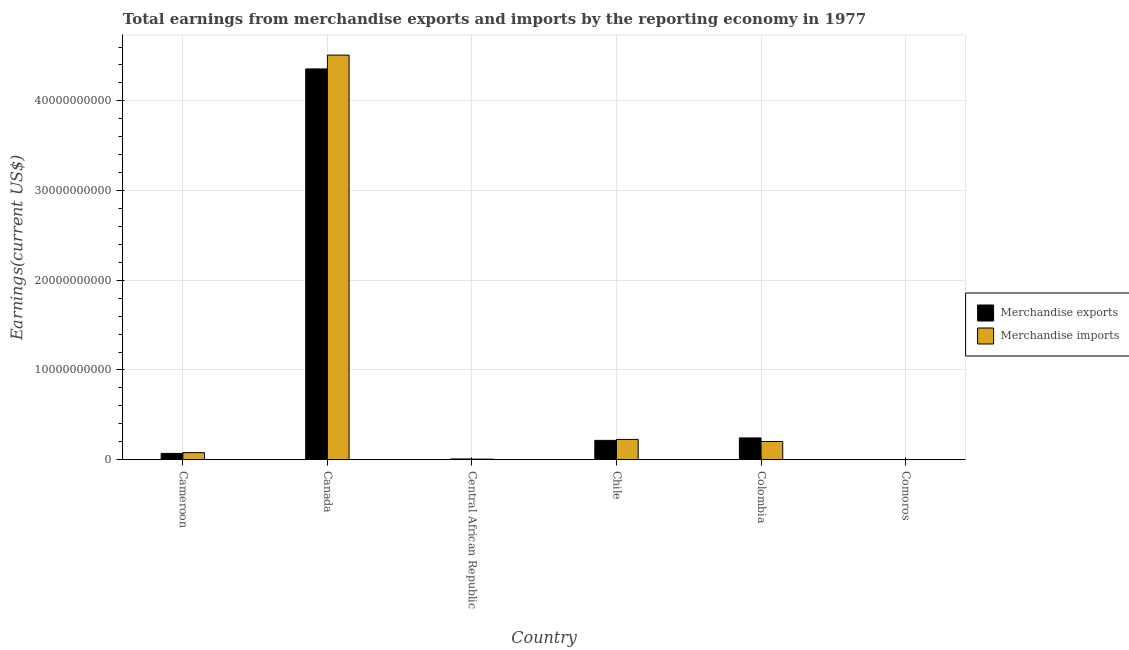How many groups of bars are there?
Provide a succinct answer. 6. Are the number of bars per tick equal to the number of legend labels?
Provide a succinct answer. Yes. Are the number of bars on each tick of the X-axis equal?
Offer a very short reply. Yes. How many bars are there on the 6th tick from the left?
Keep it short and to the point. 2. What is the label of the 2nd group of bars from the left?
Offer a terse response. Canada. What is the earnings from merchandise imports in Cameroon?
Provide a short and direct response. 7.86e+08. Across all countries, what is the maximum earnings from merchandise exports?
Give a very brief answer. 4.36e+1. Across all countries, what is the minimum earnings from merchandise exports?
Ensure brevity in your answer.  9.00e+06. In which country was the earnings from merchandise exports maximum?
Offer a terse response. Canada. In which country was the earnings from merchandise exports minimum?
Make the answer very short. Comoros. What is the total earnings from merchandise exports in the graph?
Your response must be concise. 4.89e+1. What is the difference between the earnings from merchandise imports in Central African Republic and that in Colombia?
Offer a very short reply. -1.96e+09. What is the difference between the earnings from merchandise exports in Canada and the earnings from merchandise imports in Chile?
Offer a terse response. 4.13e+1. What is the average earnings from merchandise imports per country?
Your answer should be compact. 8.37e+09. What is the difference between the earnings from merchandise imports and earnings from merchandise exports in Chile?
Ensure brevity in your answer.  1.06e+08. What is the ratio of the earnings from merchandise exports in Canada to that in Colombia?
Your answer should be very brief. 17.95. Is the difference between the earnings from merchandise imports in Cameroon and Central African Republic greater than the difference between the earnings from merchandise exports in Cameroon and Central African Republic?
Give a very brief answer. Yes. What is the difference between the highest and the second highest earnings from merchandise imports?
Provide a succinct answer. 4.28e+1. What is the difference between the highest and the lowest earnings from merchandise exports?
Give a very brief answer. 4.35e+1. Is the sum of the earnings from merchandise exports in Central African Republic and Chile greater than the maximum earnings from merchandise imports across all countries?
Offer a terse response. No. What does the 1st bar from the left in Comoros represents?
Your answer should be very brief. Merchandise exports. How many countries are there in the graph?
Make the answer very short. 6. What is the difference between two consecutive major ticks on the Y-axis?
Offer a terse response. 1.00e+1. Does the graph contain any zero values?
Your answer should be compact. No. How many legend labels are there?
Provide a short and direct response. 2. What is the title of the graph?
Make the answer very short. Total earnings from merchandise exports and imports by the reporting economy in 1977. Does "Commercial service imports" appear as one of the legend labels in the graph?
Ensure brevity in your answer.  No. What is the label or title of the Y-axis?
Your response must be concise. Earnings(current US$). What is the Earnings(current US$) of Merchandise exports in Cameroon?
Give a very brief answer. 7.02e+08. What is the Earnings(current US$) in Merchandise imports in Cameroon?
Provide a succinct answer. 7.86e+08. What is the Earnings(current US$) of Merchandise exports in Canada?
Offer a terse response. 4.36e+1. What is the Earnings(current US$) in Merchandise imports in Canada?
Give a very brief answer. 4.51e+1. What is the Earnings(current US$) in Merchandise exports in Central African Republic?
Your response must be concise. 8.13e+07. What is the Earnings(current US$) of Merchandise imports in Central African Republic?
Provide a short and direct response. 6.31e+07. What is the Earnings(current US$) in Merchandise exports in Chile?
Your response must be concise. 2.15e+09. What is the Earnings(current US$) in Merchandise imports in Chile?
Your response must be concise. 2.26e+09. What is the Earnings(current US$) in Merchandise exports in Colombia?
Offer a terse response. 2.43e+09. What is the Earnings(current US$) in Merchandise imports in Colombia?
Keep it short and to the point. 2.03e+09. What is the Earnings(current US$) of Merchandise exports in Comoros?
Offer a terse response. 9.00e+06. What is the Earnings(current US$) of Merchandise imports in Comoros?
Keep it short and to the point. 1.57e+07. Across all countries, what is the maximum Earnings(current US$) of Merchandise exports?
Ensure brevity in your answer.  4.36e+1. Across all countries, what is the maximum Earnings(current US$) of Merchandise imports?
Give a very brief answer. 4.51e+1. Across all countries, what is the minimum Earnings(current US$) of Merchandise exports?
Your answer should be very brief. 9.00e+06. Across all countries, what is the minimum Earnings(current US$) of Merchandise imports?
Provide a short and direct response. 1.57e+07. What is the total Earnings(current US$) in Merchandise exports in the graph?
Your answer should be very brief. 4.89e+1. What is the total Earnings(current US$) in Merchandise imports in the graph?
Ensure brevity in your answer.  5.02e+1. What is the difference between the Earnings(current US$) in Merchandise exports in Cameroon and that in Canada?
Your answer should be very brief. -4.29e+1. What is the difference between the Earnings(current US$) of Merchandise imports in Cameroon and that in Canada?
Offer a terse response. -4.43e+1. What is the difference between the Earnings(current US$) in Merchandise exports in Cameroon and that in Central African Republic?
Your answer should be very brief. 6.20e+08. What is the difference between the Earnings(current US$) of Merchandise imports in Cameroon and that in Central African Republic?
Provide a succinct answer. 7.23e+08. What is the difference between the Earnings(current US$) of Merchandise exports in Cameroon and that in Chile?
Provide a short and direct response. -1.45e+09. What is the difference between the Earnings(current US$) of Merchandise imports in Cameroon and that in Chile?
Your response must be concise. -1.47e+09. What is the difference between the Earnings(current US$) in Merchandise exports in Cameroon and that in Colombia?
Keep it short and to the point. -1.73e+09. What is the difference between the Earnings(current US$) in Merchandise imports in Cameroon and that in Colombia?
Offer a terse response. -1.24e+09. What is the difference between the Earnings(current US$) of Merchandise exports in Cameroon and that in Comoros?
Offer a very short reply. 6.93e+08. What is the difference between the Earnings(current US$) in Merchandise imports in Cameroon and that in Comoros?
Provide a succinct answer. 7.70e+08. What is the difference between the Earnings(current US$) of Merchandise exports in Canada and that in Central African Republic?
Provide a short and direct response. 4.35e+1. What is the difference between the Earnings(current US$) of Merchandise imports in Canada and that in Central African Republic?
Provide a short and direct response. 4.50e+1. What is the difference between the Earnings(current US$) in Merchandise exports in Canada and that in Chile?
Provide a short and direct response. 4.14e+1. What is the difference between the Earnings(current US$) in Merchandise imports in Canada and that in Chile?
Give a very brief answer. 4.28e+1. What is the difference between the Earnings(current US$) in Merchandise exports in Canada and that in Colombia?
Ensure brevity in your answer.  4.11e+1. What is the difference between the Earnings(current US$) in Merchandise imports in Canada and that in Colombia?
Your answer should be compact. 4.31e+1. What is the difference between the Earnings(current US$) of Merchandise exports in Canada and that in Comoros?
Provide a short and direct response. 4.35e+1. What is the difference between the Earnings(current US$) of Merchandise imports in Canada and that in Comoros?
Keep it short and to the point. 4.51e+1. What is the difference between the Earnings(current US$) in Merchandise exports in Central African Republic and that in Chile?
Keep it short and to the point. -2.07e+09. What is the difference between the Earnings(current US$) of Merchandise imports in Central African Republic and that in Chile?
Your answer should be compact. -2.20e+09. What is the difference between the Earnings(current US$) in Merchandise exports in Central African Republic and that in Colombia?
Your answer should be compact. -2.35e+09. What is the difference between the Earnings(current US$) in Merchandise imports in Central African Republic and that in Colombia?
Offer a very short reply. -1.96e+09. What is the difference between the Earnings(current US$) of Merchandise exports in Central African Republic and that in Comoros?
Ensure brevity in your answer.  7.23e+07. What is the difference between the Earnings(current US$) of Merchandise imports in Central African Republic and that in Comoros?
Your answer should be very brief. 4.74e+07. What is the difference between the Earnings(current US$) in Merchandise exports in Chile and that in Colombia?
Offer a terse response. -2.72e+08. What is the difference between the Earnings(current US$) of Merchandise imports in Chile and that in Colombia?
Your answer should be compact. 2.32e+08. What is the difference between the Earnings(current US$) of Merchandise exports in Chile and that in Comoros?
Provide a short and direct response. 2.15e+09. What is the difference between the Earnings(current US$) in Merchandise imports in Chile and that in Comoros?
Provide a succinct answer. 2.24e+09. What is the difference between the Earnings(current US$) of Merchandise exports in Colombia and that in Comoros?
Give a very brief answer. 2.42e+09. What is the difference between the Earnings(current US$) of Merchandise imports in Colombia and that in Comoros?
Provide a succinct answer. 2.01e+09. What is the difference between the Earnings(current US$) in Merchandise exports in Cameroon and the Earnings(current US$) in Merchandise imports in Canada?
Ensure brevity in your answer.  -4.44e+1. What is the difference between the Earnings(current US$) of Merchandise exports in Cameroon and the Earnings(current US$) of Merchandise imports in Central African Republic?
Your response must be concise. 6.39e+08. What is the difference between the Earnings(current US$) in Merchandise exports in Cameroon and the Earnings(current US$) in Merchandise imports in Chile?
Your answer should be compact. -1.56e+09. What is the difference between the Earnings(current US$) in Merchandise exports in Cameroon and the Earnings(current US$) in Merchandise imports in Colombia?
Provide a succinct answer. -1.33e+09. What is the difference between the Earnings(current US$) of Merchandise exports in Cameroon and the Earnings(current US$) of Merchandise imports in Comoros?
Offer a terse response. 6.86e+08. What is the difference between the Earnings(current US$) in Merchandise exports in Canada and the Earnings(current US$) in Merchandise imports in Central African Republic?
Your answer should be compact. 4.35e+1. What is the difference between the Earnings(current US$) of Merchandise exports in Canada and the Earnings(current US$) of Merchandise imports in Chile?
Give a very brief answer. 4.13e+1. What is the difference between the Earnings(current US$) of Merchandise exports in Canada and the Earnings(current US$) of Merchandise imports in Colombia?
Keep it short and to the point. 4.15e+1. What is the difference between the Earnings(current US$) in Merchandise exports in Canada and the Earnings(current US$) in Merchandise imports in Comoros?
Your answer should be very brief. 4.35e+1. What is the difference between the Earnings(current US$) of Merchandise exports in Central African Republic and the Earnings(current US$) of Merchandise imports in Chile?
Your answer should be very brief. -2.18e+09. What is the difference between the Earnings(current US$) of Merchandise exports in Central African Republic and the Earnings(current US$) of Merchandise imports in Colombia?
Offer a very short reply. -1.95e+09. What is the difference between the Earnings(current US$) of Merchandise exports in Central African Republic and the Earnings(current US$) of Merchandise imports in Comoros?
Your answer should be compact. 6.56e+07. What is the difference between the Earnings(current US$) in Merchandise exports in Chile and the Earnings(current US$) in Merchandise imports in Colombia?
Offer a terse response. 1.26e+08. What is the difference between the Earnings(current US$) in Merchandise exports in Chile and the Earnings(current US$) in Merchandise imports in Comoros?
Make the answer very short. 2.14e+09. What is the difference between the Earnings(current US$) of Merchandise exports in Colombia and the Earnings(current US$) of Merchandise imports in Comoros?
Give a very brief answer. 2.41e+09. What is the average Earnings(current US$) of Merchandise exports per country?
Provide a short and direct response. 8.15e+09. What is the average Earnings(current US$) of Merchandise imports per country?
Provide a succinct answer. 8.37e+09. What is the difference between the Earnings(current US$) of Merchandise exports and Earnings(current US$) of Merchandise imports in Cameroon?
Your response must be concise. -8.40e+07. What is the difference between the Earnings(current US$) of Merchandise exports and Earnings(current US$) of Merchandise imports in Canada?
Keep it short and to the point. -1.54e+09. What is the difference between the Earnings(current US$) in Merchandise exports and Earnings(current US$) in Merchandise imports in Central African Republic?
Keep it short and to the point. 1.82e+07. What is the difference between the Earnings(current US$) in Merchandise exports and Earnings(current US$) in Merchandise imports in Chile?
Provide a succinct answer. -1.06e+08. What is the difference between the Earnings(current US$) in Merchandise exports and Earnings(current US$) in Merchandise imports in Colombia?
Ensure brevity in your answer.  3.99e+08. What is the difference between the Earnings(current US$) in Merchandise exports and Earnings(current US$) in Merchandise imports in Comoros?
Your answer should be very brief. -6.70e+06. What is the ratio of the Earnings(current US$) in Merchandise exports in Cameroon to that in Canada?
Provide a short and direct response. 0.02. What is the ratio of the Earnings(current US$) in Merchandise imports in Cameroon to that in Canada?
Give a very brief answer. 0.02. What is the ratio of the Earnings(current US$) of Merchandise exports in Cameroon to that in Central African Republic?
Ensure brevity in your answer.  8.63. What is the ratio of the Earnings(current US$) of Merchandise imports in Cameroon to that in Central African Republic?
Provide a short and direct response. 12.46. What is the ratio of the Earnings(current US$) in Merchandise exports in Cameroon to that in Chile?
Provide a succinct answer. 0.33. What is the ratio of the Earnings(current US$) of Merchandise imports in Cameroon to that in Chile?
Provide a succinct answer. 0.35. What is the ratio of the Earnings(current US$) of Merchandise exports in Cameroon to that in Colombia?
Your answer should be very brief. 0.29. What is the ratio of the Earnings(current US$) of Merchandise imports in Cameroon to that in Colombia?
Offer a terse response. 0.39. What is the ratio of the Earnings(current US$) in Merchandise exports in Cameroon to that in Comoros?
Offer a very short reply. 77.96. What is the ratio of the Earnings(current US$) in Merchandise imports in Cameroon to that in Comoros?
Ensure brevity in your answer.  50.04. What is the ratio of the Earnings(current US$) in Merchandise exports in Canada to that in Central African Republic?
Ensure brevity in your answer.  535.69. What is the ratio of the Earnings(current US$) in Merchandise imports in Canada to that in Central African Republic?
Keep it short and to the point. 715.05. What is the ratio of the Earnings(current US$) of Merchandise exports in Canada to that in Chile?
Your answer should be very brief. 20.22. What is the ratio of the Earnings(current US$) of Merchandise imports in Canada to that in Chile?
Give a very brief answer. 19.95. What is the ratio of the Earnings(current US$) in Merchandise exports in Canada to that in Colombia?
Offer a terse response. 17.95. What is the ratio of the Earnings(current US$) in Merchandise imports in Canada to that in Colombia?
Provide a succinct answer. 22.24. What is the ratio of the Earnings(current US$) in Merchandise exports in Canada to that in Comoros?
Your answer should be very brief. 4839.47. What is the ratio of the Earnings(current US$) of Merchandise imports in Canada to that in Comoros?
Ensure brevity in your answer.  2872.42. What is the ratio of the Earnings(current US$) in Merchandise exports in Central African Republic to that in Chile?
Your response must be concise. 0.04. What is the ratio of the Earnings(current US$) in Merchandise imports in Central African Republic to that in Chile?
Provide a short and direct response. 0.03. What is the ratio of the Earnings(current US$) in Merchandise exports in Central African Republic to that in Colombia?
Your answer should be compact. 0.03. What is the ratio of the Earnings(current US$) of Merchandise imports in Central African Republic to that in Colombia?
Provide a succinct answer. 0.03. What is the ratio of the Earnings(current US$) in Merchandise exports in Central African Republic to that in Comoros?
Provide a short and direct response. 9.03. What is the ratio of the Earnings(current US$) of Merchandise imports in Central African Republic to that in Comoros?
Your answer should be compact. 4.02. What is the ratio of the Earnings(current US$) in Merchandise exports in Chile to that in Colombia?
Ensure brevity in your answer.  0.89. What is the ratio of the Earnings(current US$) of Merchandise imports in Chile to that in Colombia?
Make the answer very short. 1.11. What is the ratio of the Earnings(current US$) in Merchandise exports in Chile to that in Comoros?
Your answer should be compact. 239.36. What is the ratio of the Earnings(current US$) in Merchandise imports in Chile to that in Comoros?
Offer a terse response. 143.96. What is the ratio of the Earnings(current US$) of Merchandise exports in Colombia to that in Comoros?
Ensure brevity in your answer.  269.63. What is the ratio of the Earnings(current US$) of Merchandise imports in Colombia to that in Comoros?
Offer a very short reply. 129.16. What is the difference between the highest and the second highest Earnings(current US$) of Merchandise exports?
Provide a succinct answer. 4.11e+1. What is the difference between the highest and the second highest Earnings(current US$) in Merchandise imports?
Make the answer very short. 4.28e+1. What is the difference between the highest and the lowest Earnings(current US$) in Merchandise exports?
Provide a succinct answer. 4.35e+1. What is the difference between the highest and the lowest Earnings(current US$) of Merchandise imports?
Make the answer very short. 4.51e+1. 